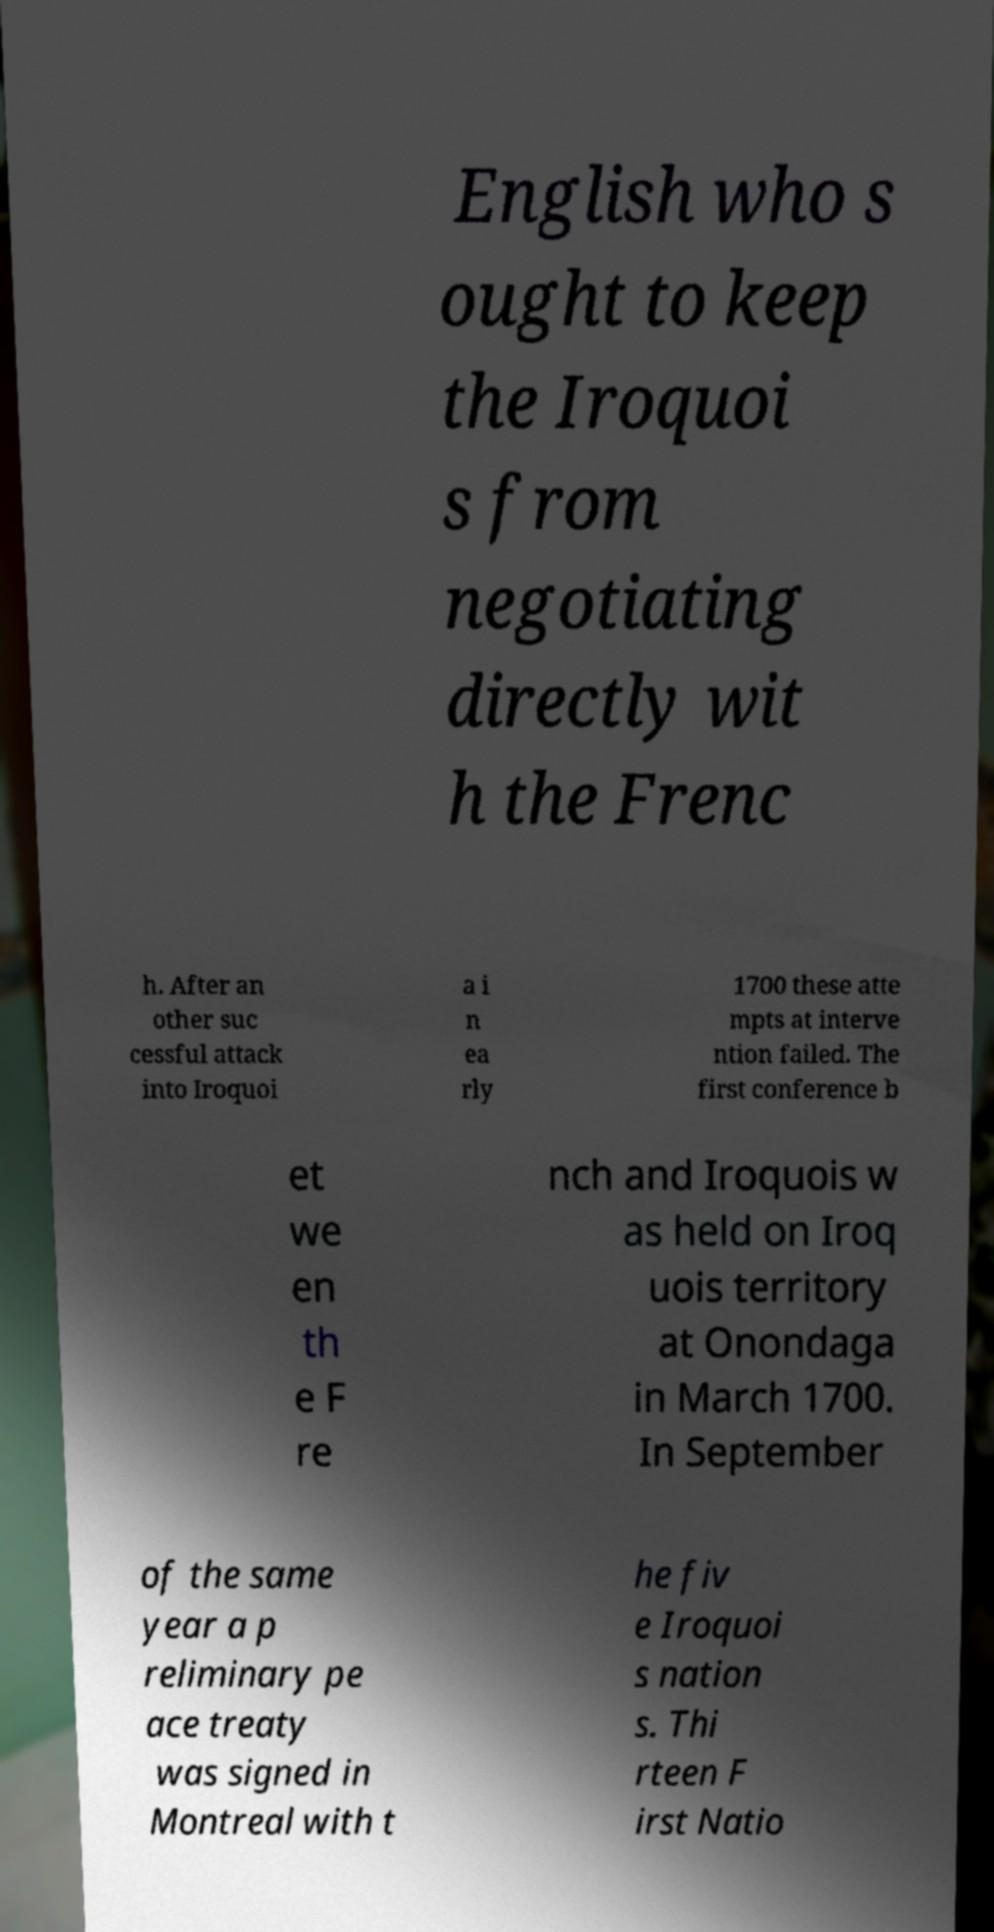Please read and relay the text visible in this image. What does it say? English who s ought to keep the Iroquoi s from negotiating directly wit h the Frenc h. After an other suc cessful attack into Iroquoi a i n ea rly 1700 these atte mpts at interve ntion failed. The first conference b et we en th e F re nch and Iroquois w as held on Iroq uois territory at Onondaga in March 1700. In September of the same year a p reliminary pe ace treaty was signed in Montreal with t he fiv e Iroquoi s nation s. Thi rteen F irst Natio 